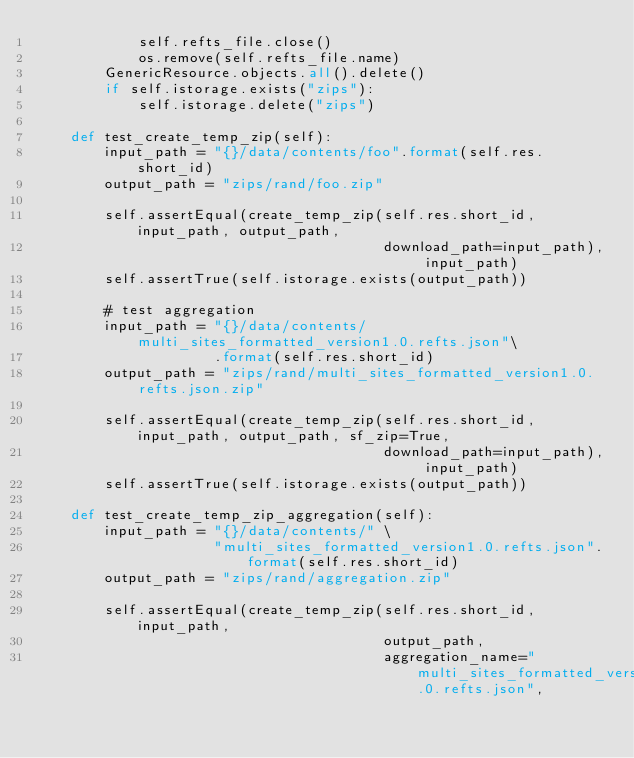Convert code to text. <code><loc_0><loc_0><loc_500><loc_500><_Python_>            self.refts_file.close()
            os.remove(self.refts_file.name)
        GenericResource.objects.all().delete()
        if self.istorage.exists("zips"):
            self.istorage.delete("zips")

    def test_create_temp_zip(self):
        input_path = "{}/data/contents/foo".format(self.res.short_id)
        output_path = "zips/rand/foo.zip"

        self.assertEqual(create_temp_zip(self.res.short_id, input_path, output_path,
                                         download_path=input_path), input_path)
        self.assertTrue(self.istorage.exists(output_path))

        # test aggregation
        input_path = "{}/data/contents/multi_sites_formatted_version1.0.refts.json"\
                     .format(self.res.short_id)
        output_path = "zips/rand/multi_sites_formatted_version1.0.refts.json.zip"

        self.assertEqual(create_temp_zip(self.res.short_id, input_path, output_path, sf_zip=True,
                                         download_path=input_path), input_path)
        self.assertTrue(self.istorage.exists(output_path))

    def test_create_temp_zip_aggregation(self):
        input_path = "{}/data/contents/" \
                     "multi_sites_formatted_version1.0.refts.json".format(self.res.short_id)
        output_path = "zips/rand/aggregation.zip"

        self.assertEqual(create_temp_zip(self.res.short_id, input_path,
                                         output_path,
                                         aggregation_name="multi_sites_formatted_version1.0.refts.json",</code> 